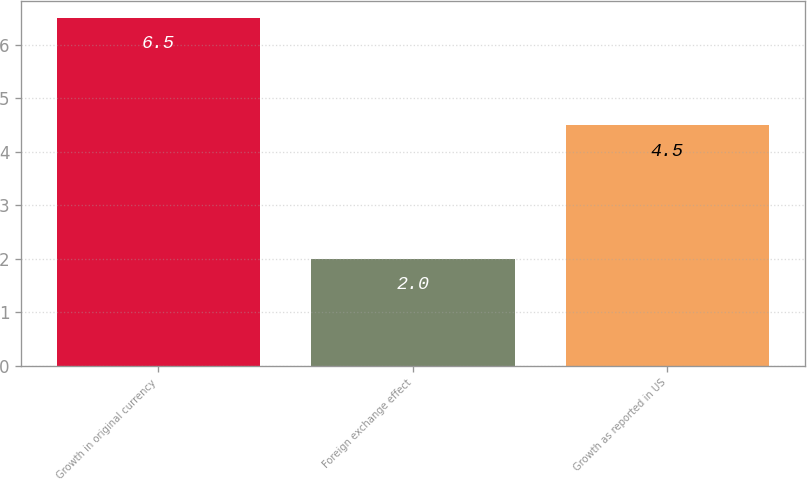Convert chart. <chart><loc_0><loc_0><loc_500><loc_500><bar_chart><fcel>Growth in original currency<fcel>Foreign exchange effect<fcel>Growth as reported in US<nl><fcel>6.5<fcel>2<fcel>4.5<nl></chart> 